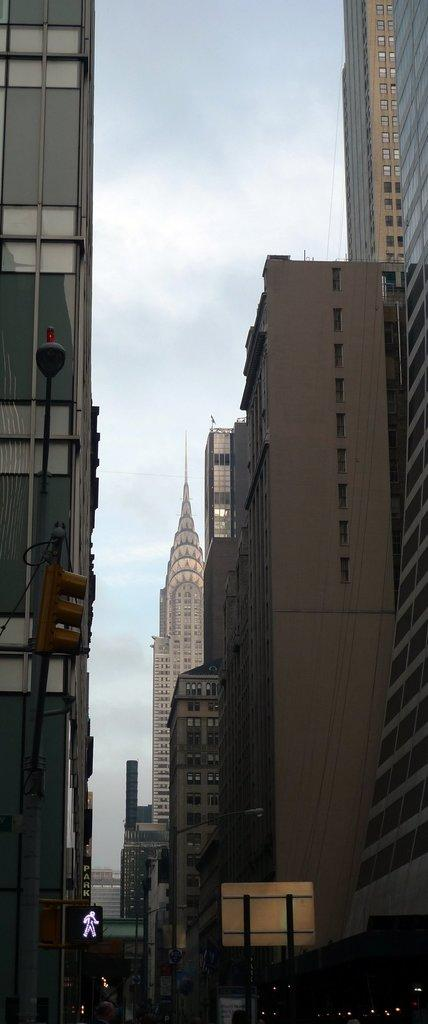What type of structures are present in the image? There are buildings in the image. What colors can be seen on the buildings? The buildings have cream, white, and brown colors. What is visible in the background of the image? The sky is visible in the background of the image. What colors are present in the sky? The sky has blue and white colors. What type of pen is the son using to write on the wool in the image? There is no pen, son, or wool present in the image. 